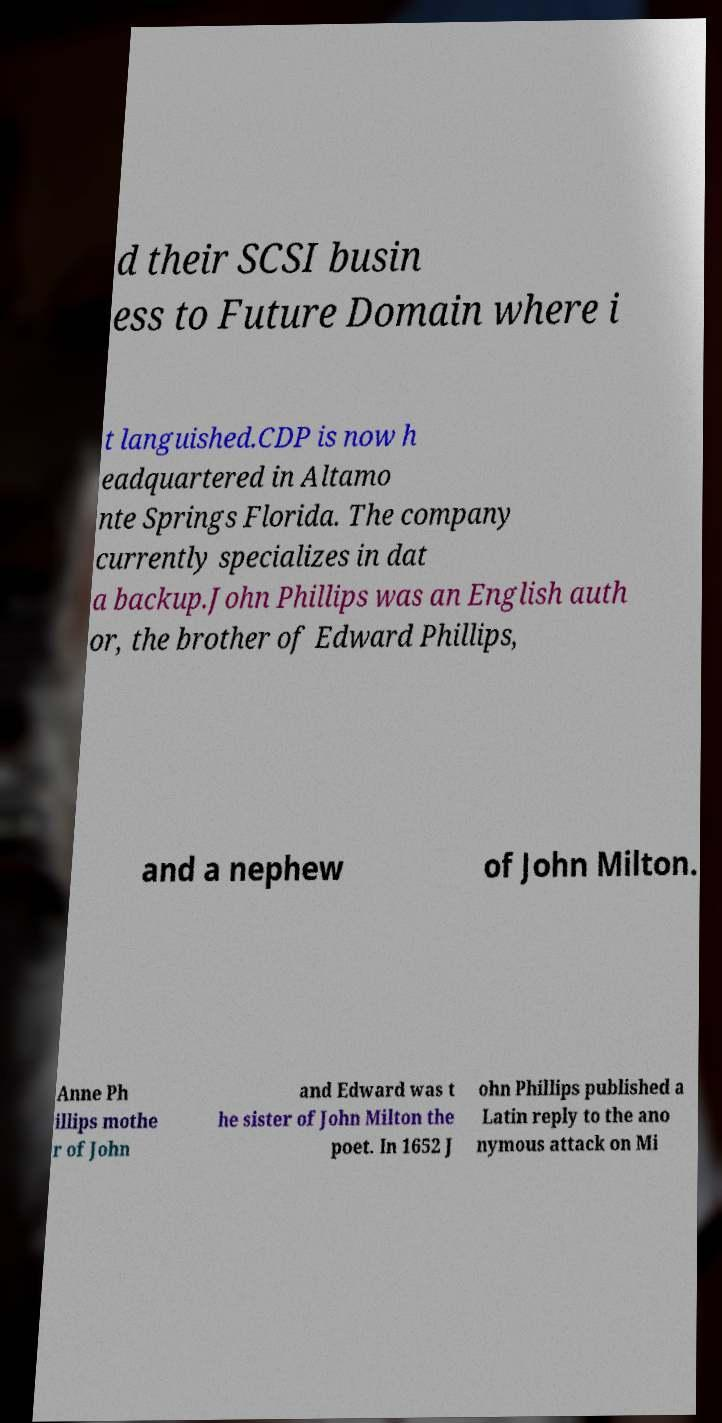There's text embedded in this image that I need extracted. Can you transcribe it verbatim? d their SCSI busin ess to Future Domain where i t languished.CDP is now h eadquartered in Altamo nte Springs Florida. The company currently specializes in dat a backup.John Phillips was an English auth or, the brother of Edward Phillips, and a nephew of John Milton. Anne Ph illips mothe r of John and Edward was t he sister of John Milton the poet. In 1652 J ohn Phillips published a Latin reply to the ano nymous attack on Mi 